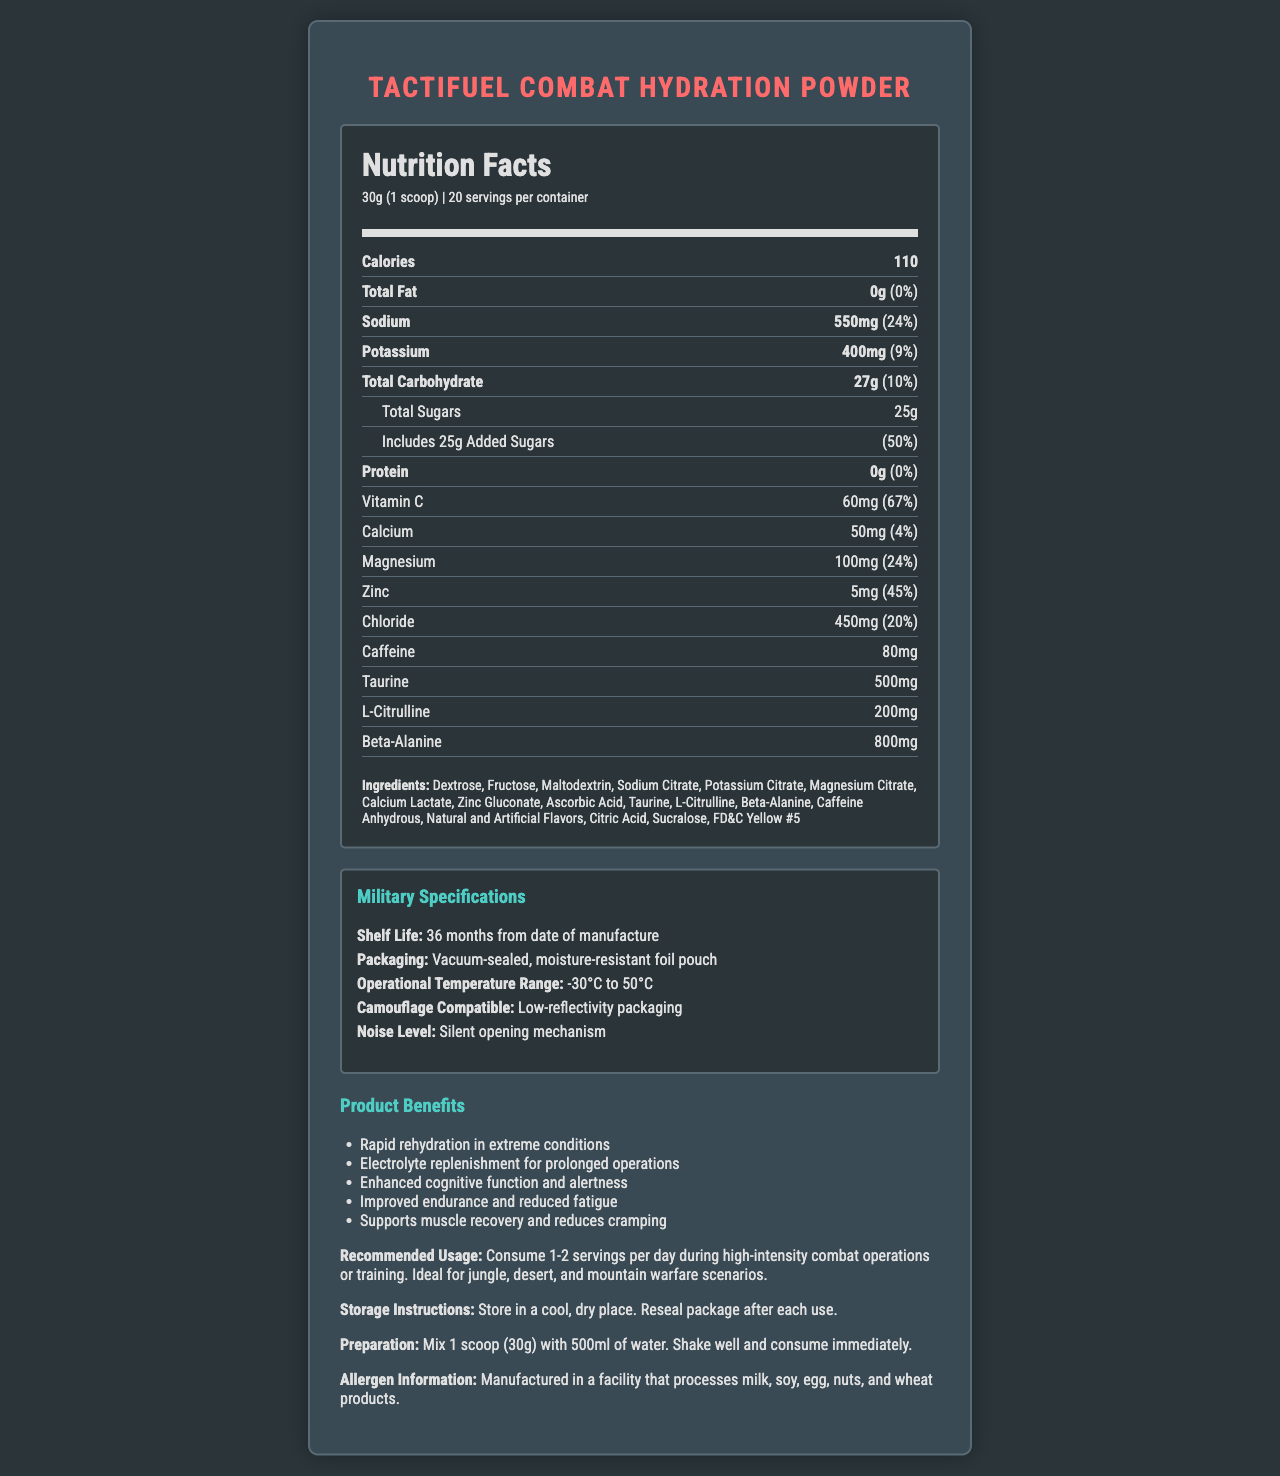what is the product name? The product name is displayed prominently at the top of the document.
Answer: TactiFuel Combat Hydration Powder what is the serving size of TactiFuel Combat Hydration Powder? The serving size is clearly mentioned right under the product name and the title "Nutrition Facts."
Answer: 30g (1 scoop) how many servings are there per container? The number of servings per container is mentioned in the serving information section under the "Nutrition Facts" title.
Answer: 20 how many calories are in one serving? The number of calories per serving is listed as the first item in the nutrition label.
Answer: 110 what is the shelf life of the product according to military specifications? The shelf life is listed under the Military Specifications section.
Answer: 36 months from date of manufacture does this product contain any fat? The nutrition label shows that the total fat content is 0g, which means the product does not contain any fat.
Answer: No how much sugar is included per serving? The amount of total sugars per serving is specified under the Total Carbohydrate section.
Answer: 25g which mineral has the highest daily value percentage? A. Sodium B. Potassium C. Magnesium D. Zinc Sodium has a daily value percentage of 24%, which is the highest among the listed minerals.
Answer: A. Sodium how much caffeine is in a serving of TactiFuel Combat Hydration Powder? A. 60mg B. 70mg C. 80mg D. 90mg The document lists the caffeine content as 80mg per serving.
Answer: C. 80mg is the package easy to open silently? The document specifies that the product packaging has a silent opening mechanism under the Military Specifications section.
Answer: Yes summarize the main purpose and benefits of TactiFuel Combat Hydration Powder. The document highlights the product benefits, military specifications, and nutritional content that support these functionalities.
Answer: The main purpose of TactiFuel Combat Hydration Powder is to provide rapid rehydration, electrolyte replenishment, enhanced cognitive function, improved endurance, reduced fatigue, and support for muscle recovery during intense physical activities in extreme combat environments. can this product be safely consumed by someone with a milk allergy? The document mentions that the product is manufactured in a facility that processes milk, but does not specify cross-contamination risks.
Answer: Cannot be determined how should the product be stored after opening? The storage instructions provide clear guidance on how to keep the product after opening.
Answer: Store in a cool, dry place. Reseal package after each use. which vitamins and minerals are included in this hydration powder? These vitamins and minerals are listed under their respective categories in the nutrition label section.
Answer: Vitamin C, calcium, magnesium, zinc, and chloride are there artificial ingredients included in the product? The ingredients list mentions "Artificial Flavors" and "FD&C Yellow #5," indicating the presence of artificial ingredients.
Answer: Yes 